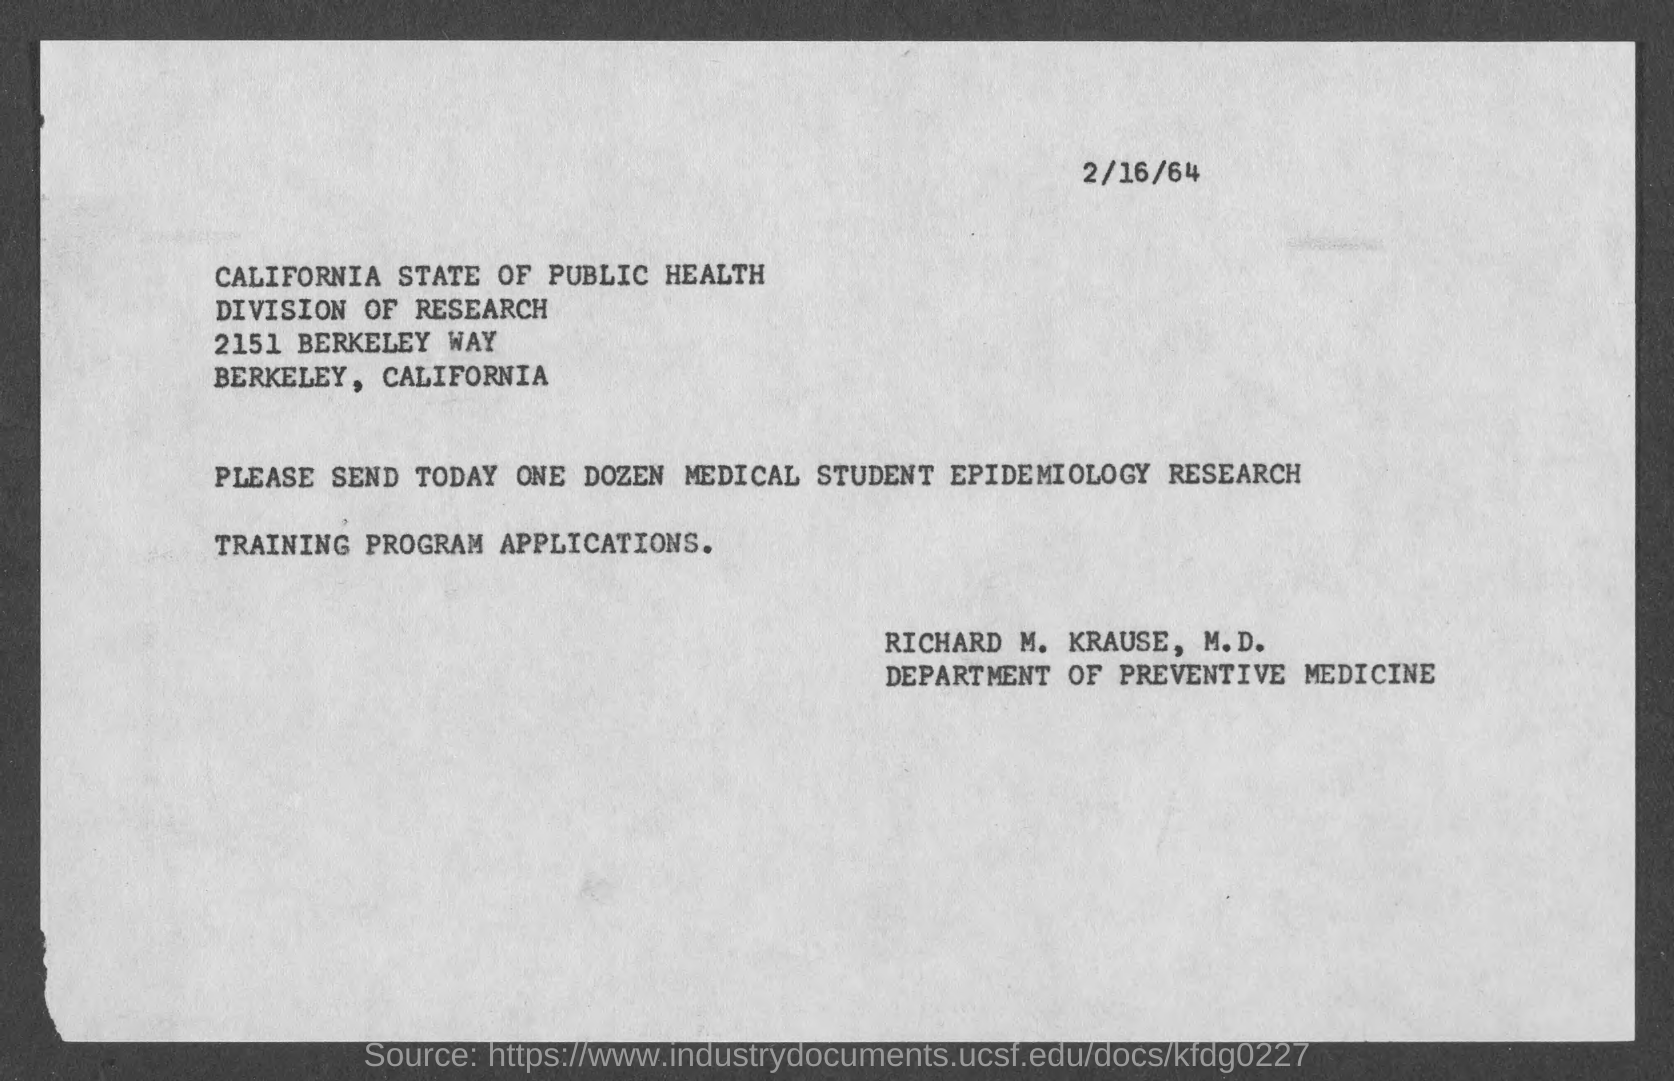Indicate a few pertinent items in this graphic. It is necessary to submit ONE DOZEN Medical student epidemiology research Training program applications. The date on the document is February 16, 1964. 